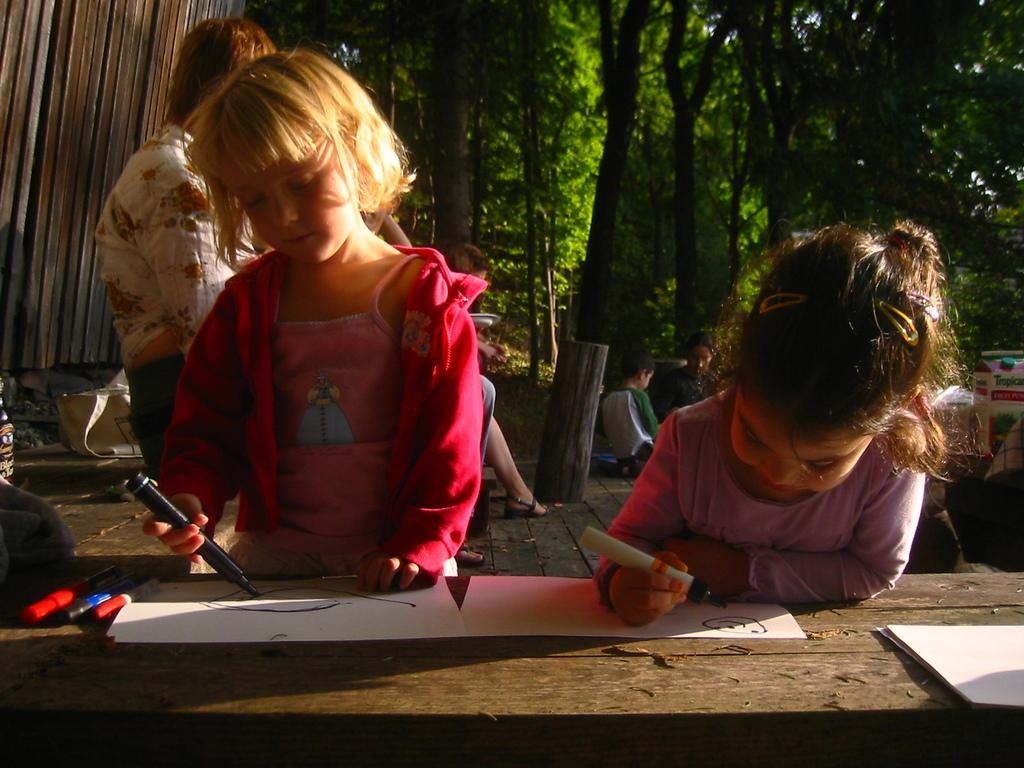In one or two sentences, can you explain what this image depicts? In this image, we can see a few people. Few are holding sketches. At the bottom, there is a wooden table, few papers sketch pens are placed on it. Background we can see bag, wooden poles, trees. 